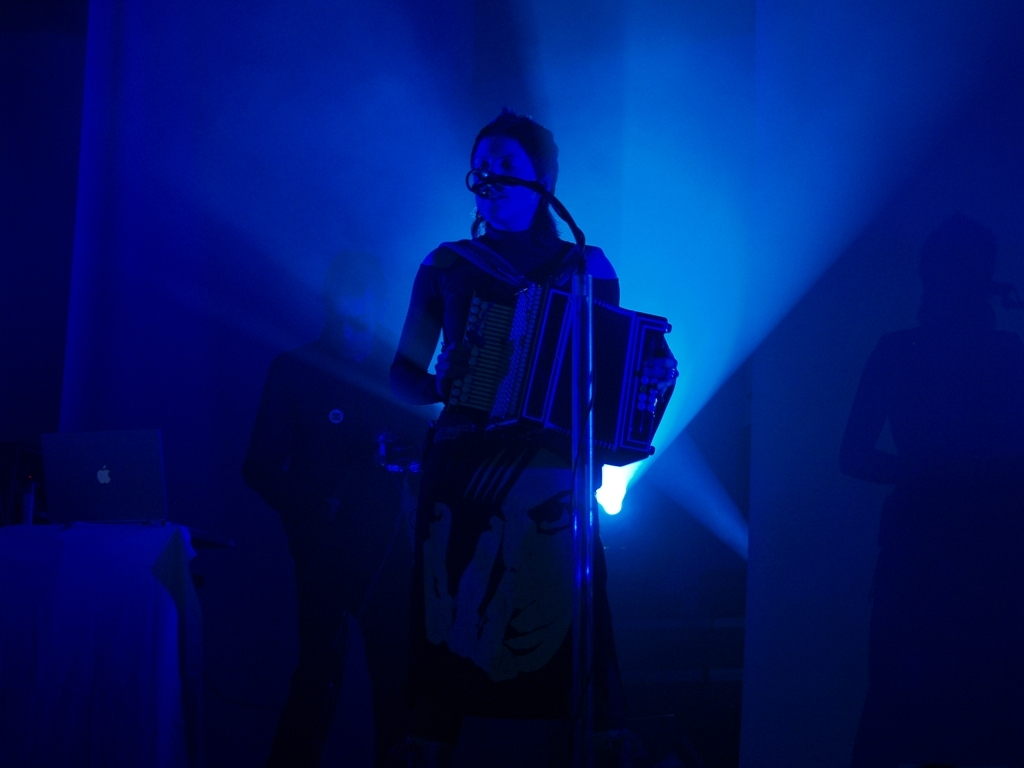Can you tell me more about the instrument the person is playing? Certainly! The person is playing an accordion, a portable musical instrument that produces sound by expanding and compressing a bellows while pressing buttons or keys to open valves and allow air to flow across strips of brass or steel, creating notes. What kind of music might be played with that instrument? Accordions are quite versatile and can be used to play various genres including folk, classical, jazz, and even rock. The style of music typically depends on the cultural context and the musician's preference. 